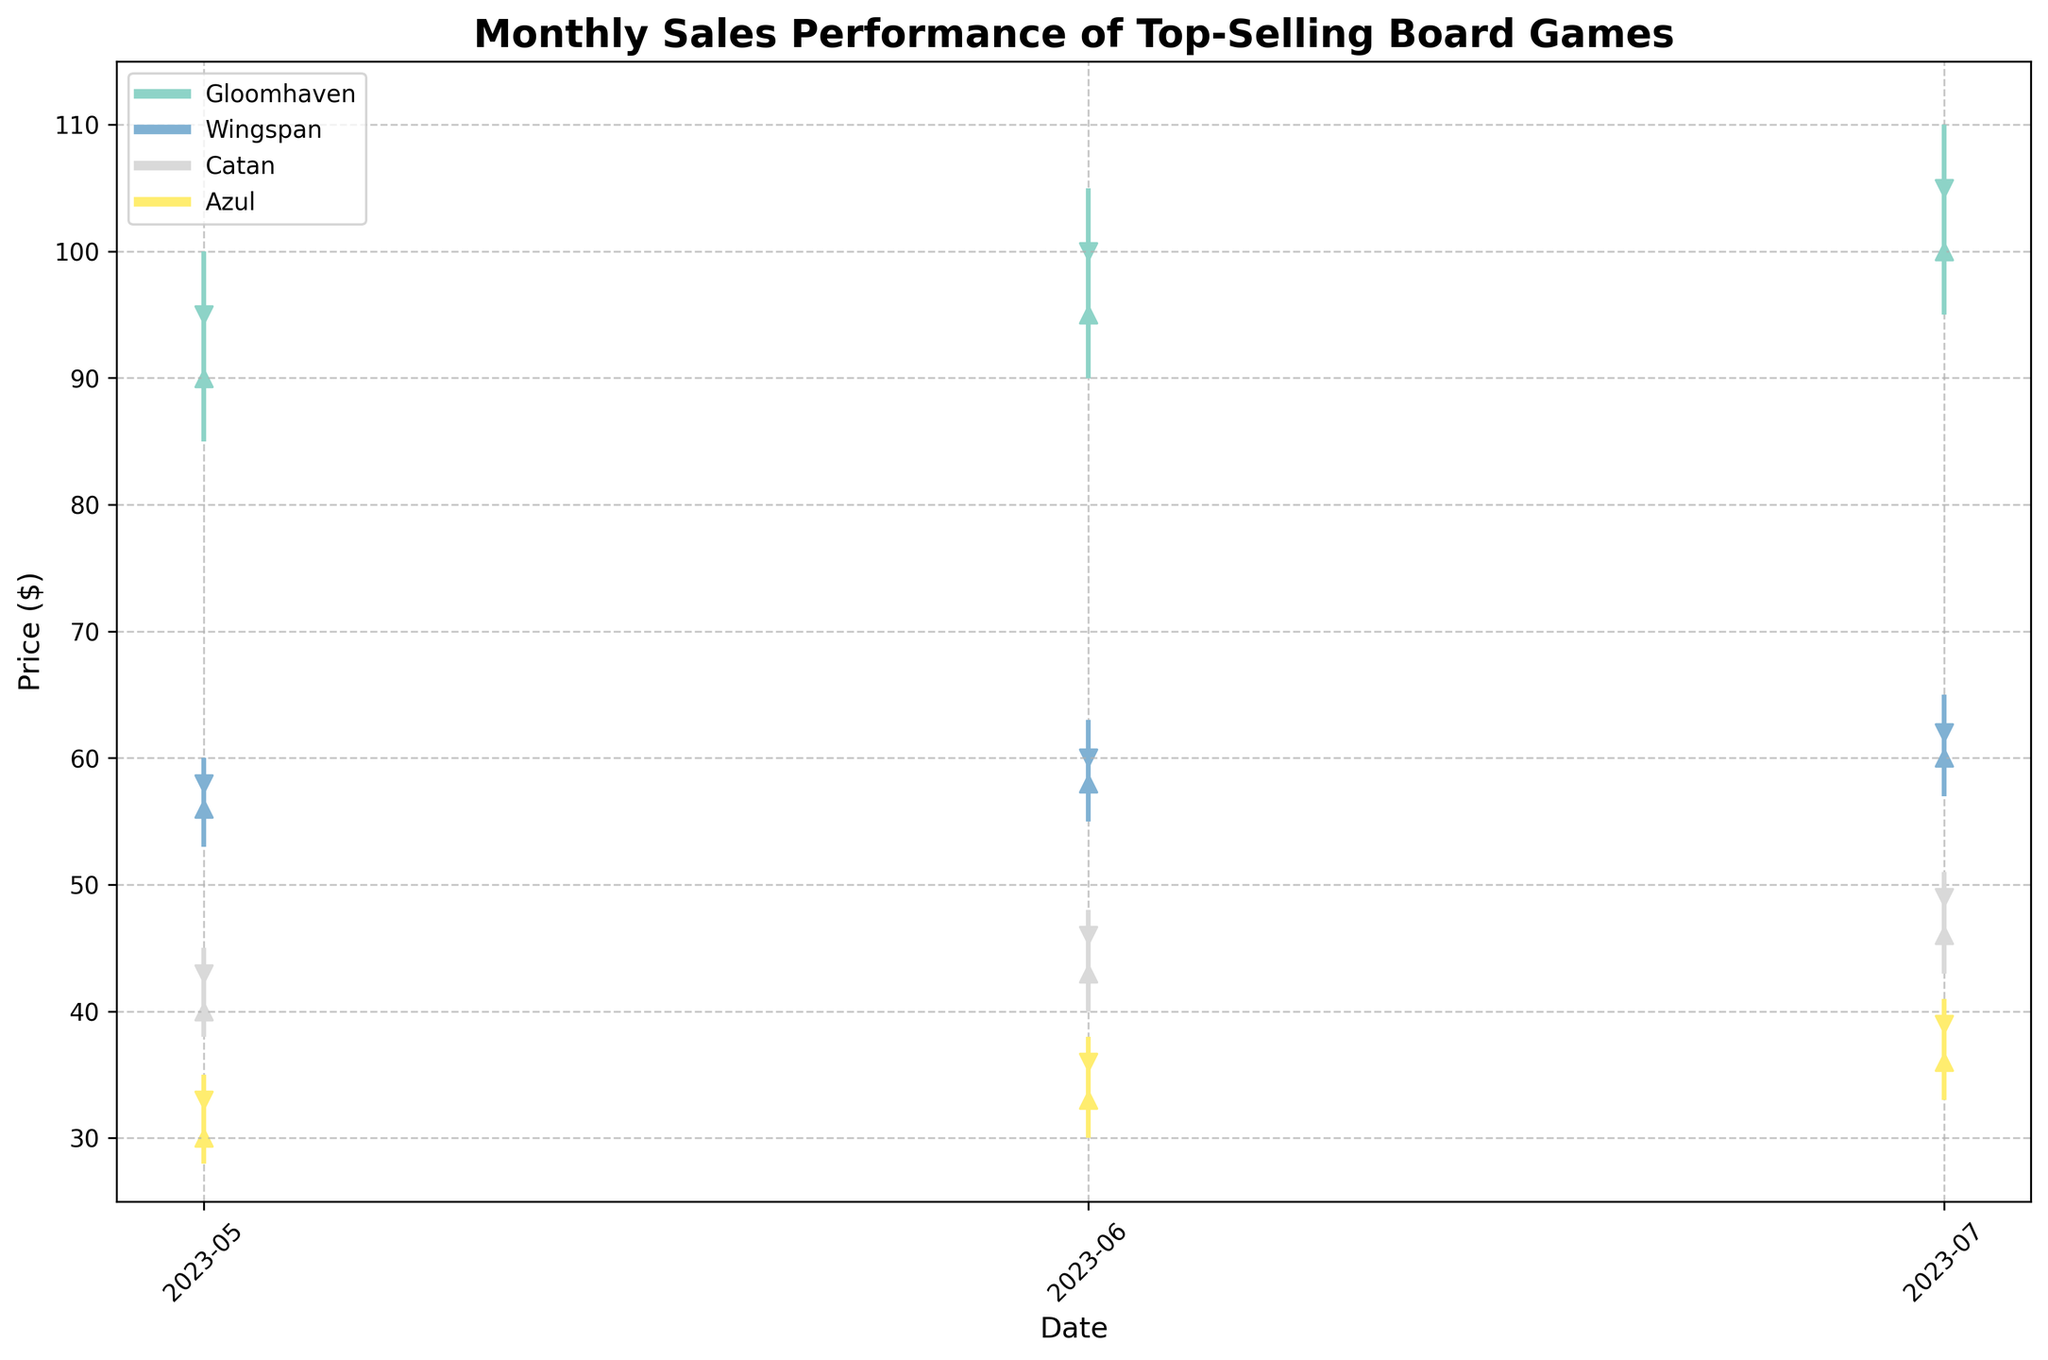what is the title of the figure? The title of the figure is usually displayed prominently at the top. Here, we see "Monthly Sales Performance of Top-Selling Board Games."
Answer: Monthly Sales Performance of Top-Selling Board Games what is the highest price recorded for Gloomhaven and in which month? To find the highest price for Gloomhaven, we look at the peaks of the vertical lines in the chart. The highest price for Gloomhaven is found in July at $109.99.
Answer: $109.99 in July which game saw the most price increase from May to July? We compare the opening prices in May and the closing prices in July for each game. Gloomhaven increased from $89.99 to $104.99, Wingspan from $55.99 to $61.99, Catan from $39.99 to $48.99, and Azul from $29.99 to $38.99. Gloomhaven saw the largest increase of $15.
Answer: Gloomhaven what is the average closing price of Wingspan over the three months? We sum the closing prices for Wingspan in May ($57.99), June ($59.99), and July ($61.99), which equals $179.97. Dividing by 3 gives an average of $59.99.
Answer: $59.99 Did Catan's price ever drop below $40? By looking at the low points for Catan in each month, we see that in May the low was $37.99, which is less than $40.
Answer: Yes How does the price range of Azul in July compare to its range in May? For comparison, we calculate the price range (high minus low) for Azul. In May, the range is $34.99 - $27.99 = $7. In July, it's $40.99 - $32.99 = $8.
Answer: July range is $1 higher than May which game had the least price fluctuation over the three months? We calculate the difference between the highest high and the lowest low prices for each game over the three months: Gloomhaven: $109.99 - $84.99 = $25, Wingspan: $64.99 - $52.99 = $12, Catan: $50.99 - $37.99 = $13, and Azul: $40.99 - $27.99 = $13. Wingspan had the least fluctuation of $12.
Answer: Wingspan what are the retailers for each game? Retailers are listed by game: Gloomhaven (Amazon), Wingspan (Target), Catan (Walmart), and Azul (Barnes & Noble).
Answer: Amazon, Target, Walmart, and Barnes & Noble 